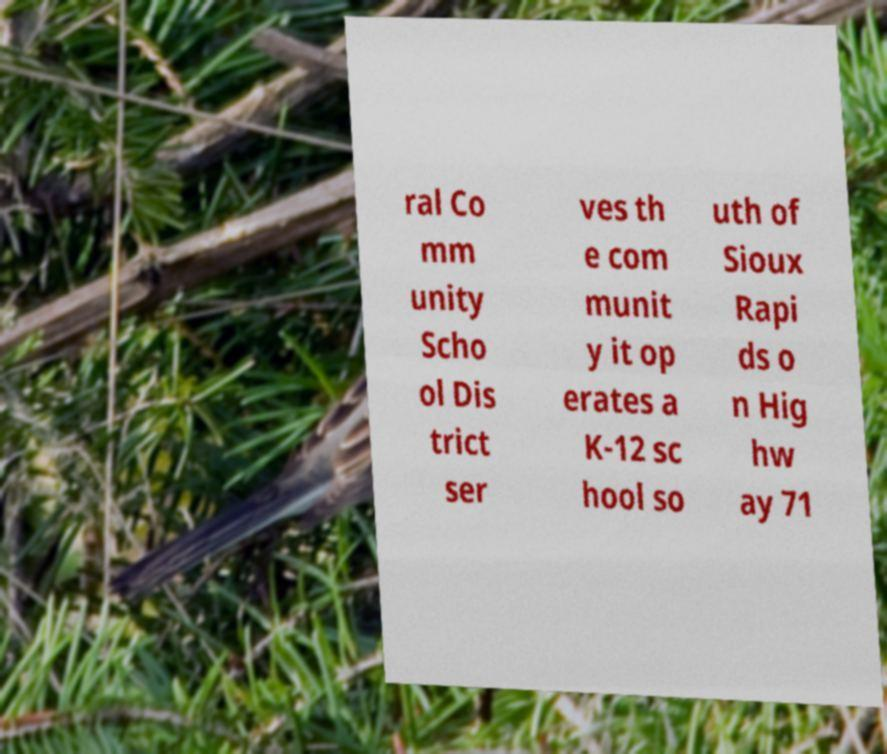Please identify and transcribe the text found in this image. ral Co mm unity Scho ol Dis trict ser ves th e com munit y it op erates a K-12 sc hool so uth of Sioux Rapi ds o n Hig hw ay 71 